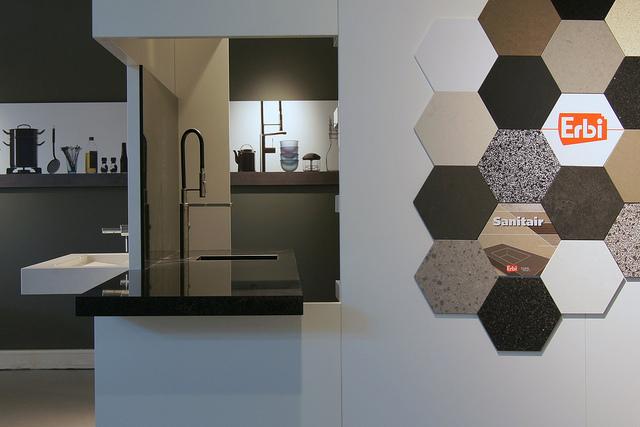What shape is the wall decoration?
Write a very short answer. Hexagon. What color is the countertop?
Concise answer only. Black. Does this room look old fashioned?
Be succinct. No. 